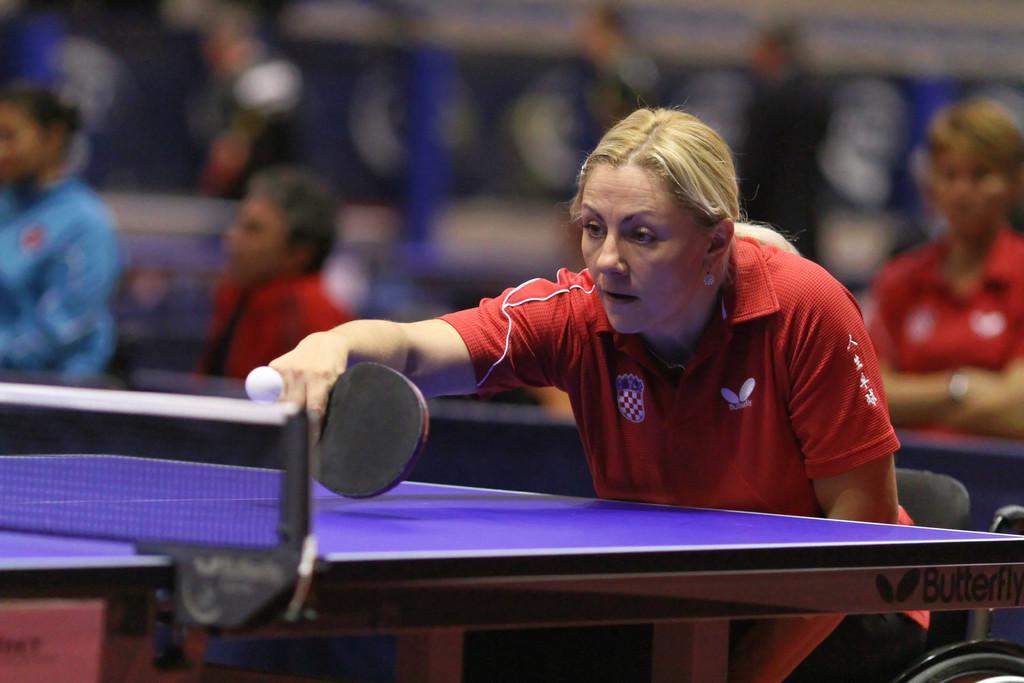Could you give a brief overview of what you see in this image? In the image there is a woman playing table tennis, in the background there are many audience looking at game. 